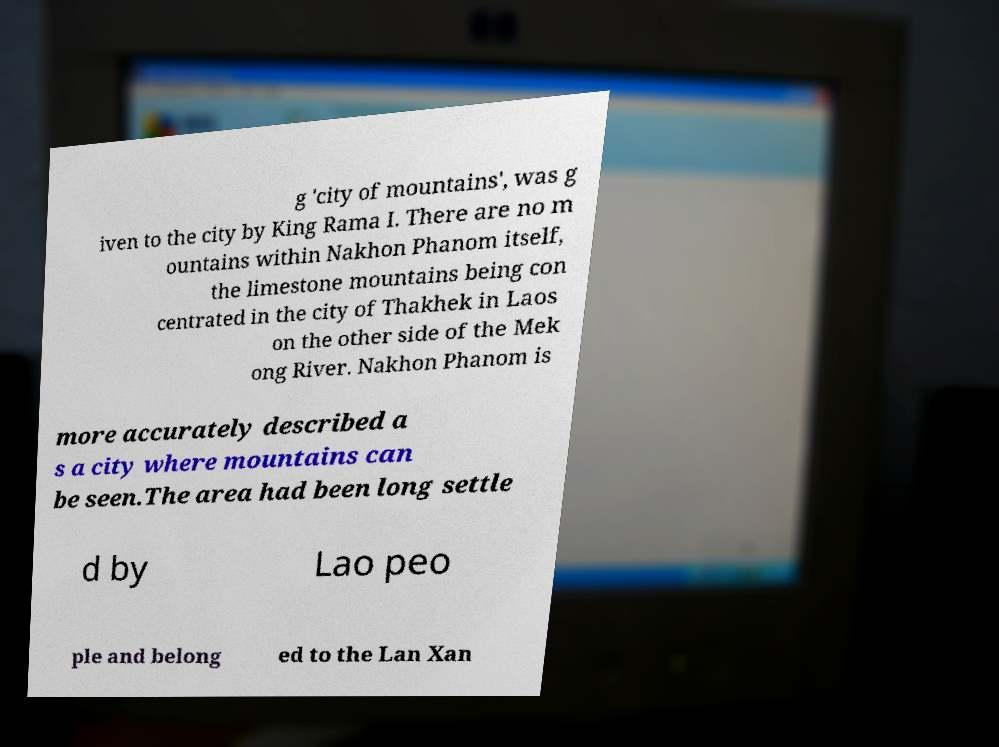Could you assist in decoding the text presented in this image and type it out clearly? g 'city of mountains', was g iven to the city by King Rama I. There are no m ountains within Nakhon Phanom itself, the limestone mountains being con centrated in the city of Thakhek in Laos on the other side of the Mek ong River. Nakhon Phanom is more accurately described a s a city where mountains can be seen.The area had been long settle d by Lao peo ple and belong ed to the Lan Xan 